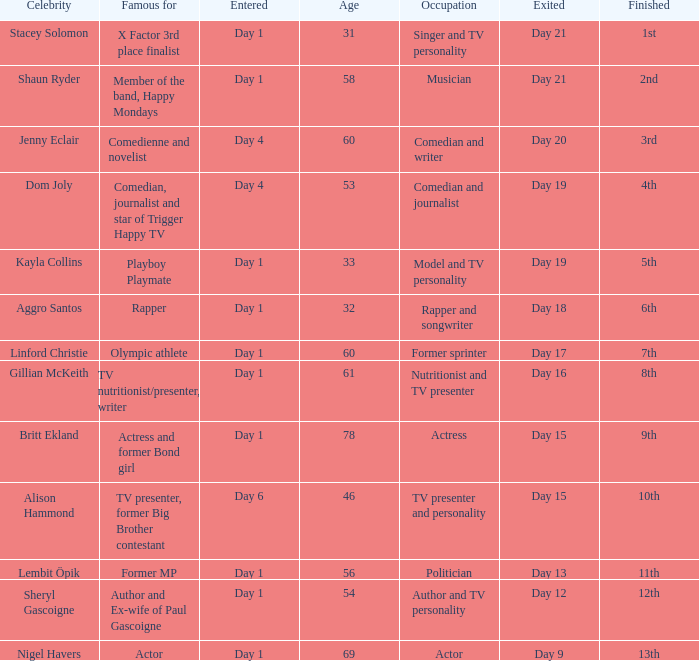What position did the celebrity finish that entered on day 1 and exited on day 19? 5th. 